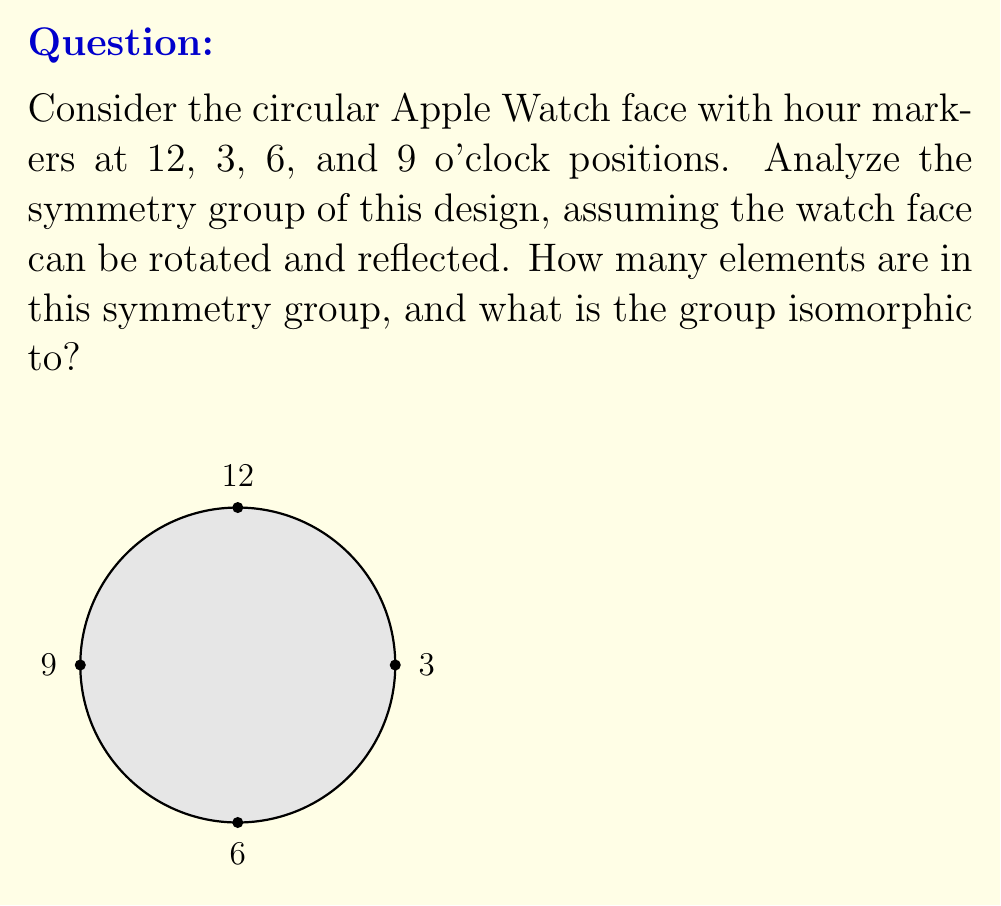Help me with this question. Let's analyze the symmetry group step-by-step:

1) Rotational symmetries:
   - The watch face can be rotated by 0°, 90°, 180°, and 270°.
   - This gives us 4 rotational symmetries.

2) Reflection symmetries:
   - There are 4 lines of reflection: vertical, horizontal, and two diagonal lines.
   - This gives us 4 reflection symmetries.

3) Total number of symmetries:
   - The total number of symmetries is the sum of rotational and reflection symmetries.
   - Total = 4 + 4 = 8 symmetries

4) Group structure:
   - This group of 8 symmetries is known as the dihedral group of order 8, denoted as $D_4$ or $D_8$ (depending on the notation system).
   - It contains rotations and reflections that preserve the square formed by the hour markers.

5) Group isomorphism:
   - The symmetry group of this Apple Watch face is isomorphic to $D_4$ (or $D_8$).
   - $D_4$ is defined as $\langle r,s | r^4 = s^2 = 1, srs = r^{-1} \rangle$, where $r$ represents rotation and $s$ represents reflection.

Therefore, the symmetry group has 8 elements and is isomorphic to the dihedral group $D_4$ (or $D_8$).
Answer: 8 elements; isomorphic to $D_4$ 